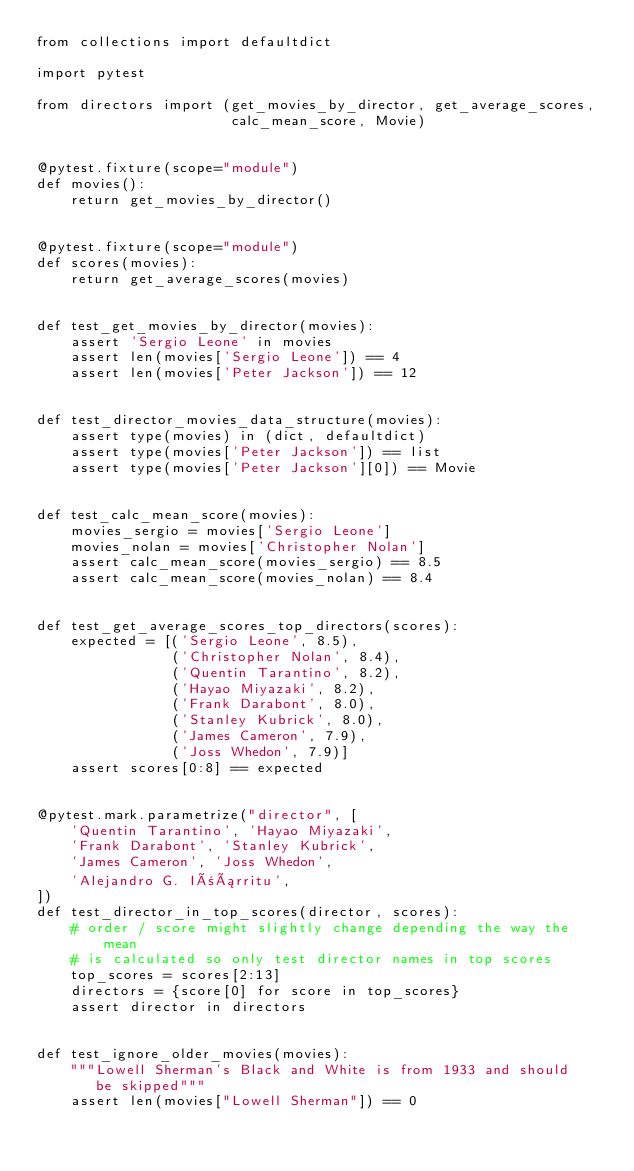<code> <loc_0><loc_0><loc_500><loc_500><_Python_>from collections import defaultdict

import pytest

from directors import (get_movies_by_director, get_average_scores,
                       calc_mean_score, Movie)


@pytest.fixture(scope="module")
def movies():
    return get_movies_by_director()


@pytest.fixture(scope="module")
def scores(movies):
    return get_average_scores(movies)


def test_get_movies_by_director(movies):
    assert 'Sergio Leone' in movies
    assert len(movies['Sergio Leone']) == 4
    assert len(movies['Peter Jackson']) == 12


def test_director_movies_data_structure(movies):
    assert type(movies) in (dict, defaultdict)
    assert type(movies['Peter Jackson']) == list
    assert type(movies['Peter Jackson'][0]) == Movie


def test_calc_mean_score(movies):
    movies_sergio = movies['Sergio Leone']
    movies_nolan = movies['Christopher Nolan']
    assert calc_mean_score(movies_sergio) == 8.5
    assert calc_mean_score(movies_nolan) == 8.4


def test_get_average_scores_top_directors(scores):
    expected = [('Sergio Leone', 8.5),
                ('Christopher Nolan', 8.4),
                ('Quentin Tarantino', 8.2),
                ('Hayao Miyazaki', 8.2),
                ('Frank Darabont', 8.0),
                ('Stanley Kubrick', 8.0),
                ('James Cameron', 7.9),
                ('Joss Whedon', 7.9)]
    assert scores[0:8] == expected


@pytest.mark.parametrize("director", [
    'Quentin Tarantino', 'Hayao Miyazaki',
    'Frank Darabont', 'Stanley Kubrick',
    'James Cameron', 'Joss Whedon',
    'Alejandro G. Iñárritu',
])
def test_director_in_top_scores(director, scores):
    # order / score might slightly change depending the way the mean
    # is calculated so only test director names in top scores
    top_scores = scores[2:13]
    directors = {score[0] for score in top_scores}
    assert director in directors


def test_ignore_older_movies(movies):
    """Lowell Sherman's Black and White is from 1933 and should
       be skipped"""
    assert len(movies["Lowell Sherman"]) == 0
</code> 